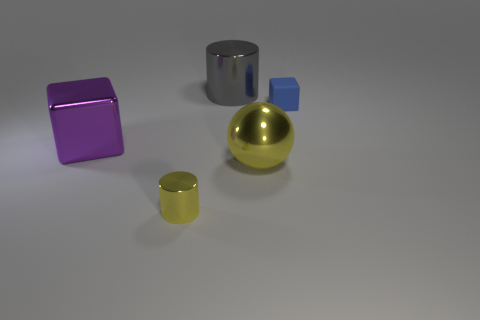Add 4 small red blocks. How many objects exist? 9 Subtract all cylinders. How many objects are left? 3 Subtract 0 blue balls. How many objects are left? 5 Subtract all yellow cylinders. Subtract all brown spheres. How many cylinders are left? 1 Subtract all small blue rubber cubes. Subtract all big metal spheres. How many objects are left? 3 Add 2 big balls. How many big balls are left? 3 Add 1 blocks. How many blocks exist? 3 